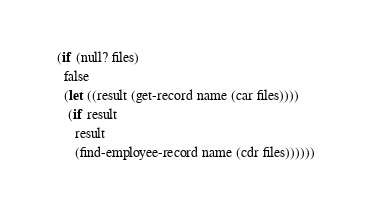Convert code to text. <code><loc_0><loc_0><loc_500><loc_500><_Scheme_>  (if (null? files)
    false
    (let ((result (get-record name (car files))))
     (if result
       result
       (find-employee-record name (cdr files))))))

</code> 